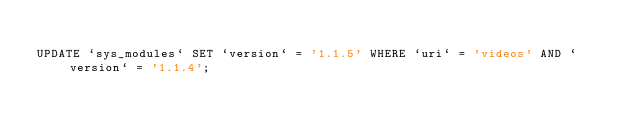Convert code to text. <code><loc_0><loc_0><loc_500><loc_500><_SQL_>
UPDATE `sys_modules` SET `version` = '1.1.5' WHERE `uri` = 'videos' AND `version` = '1.1.4';

</code> 